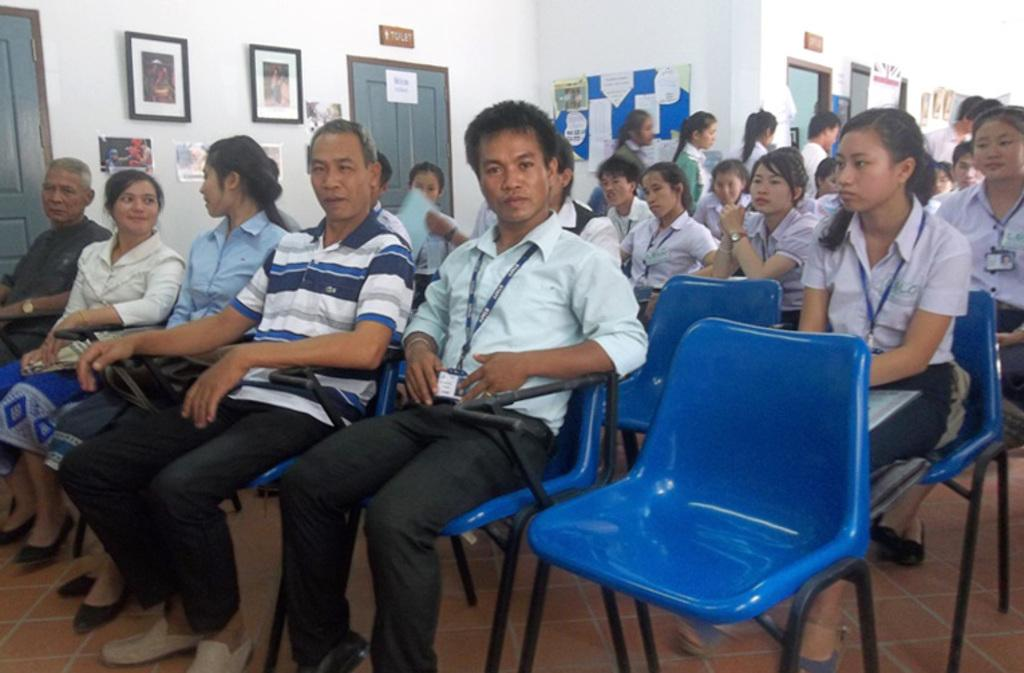What color are the chairs that the people are sitting on? The chairs are blue. What can be seen behind the people sitting on the chairs? There is a white wall in the background. What is hanging on the white wall? There are photo frames on the white wall. What architectural feature is present on the white wall? There are doors on the white wall. How does the dock contribute to the overall atmosphere of the image? There is no dock present in the image, so it cannot contribute to the overall atmosphere. 